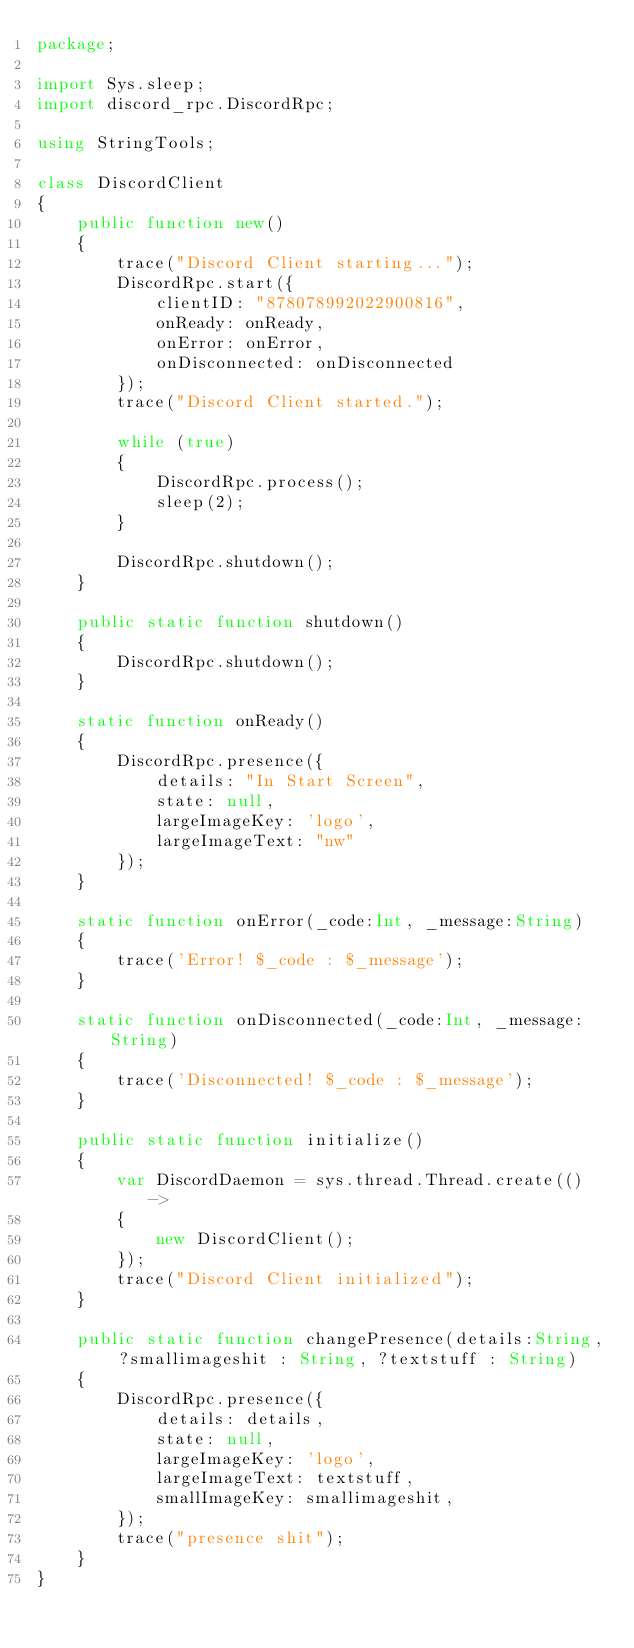<code> <loc_0><loc_0><loc_500><loc_500><_Haxe_>package;

import Sys.sleep;
import discord_rpc.DiscordRpc;

using StringTools;

class DiscordClient
{
	public function new()
	{
		trace("Discord Client starting...");
		DiscordRpc.start({
			clientID: "878078992022900816",
			onReady: onReady,
			onError: onError,
			onDisconnected: onDisconnected
		});
		trace("Discord Client started.");

		while (true)
		{
			DiscordRpc.process();
			sleep(2);
		}

		DiscordRpc.shutdown();
	}

	public static function shutdown()
	{
		DiscordRpc.shutdown();
	}

	static function onReady()
	{
		DiscordRpc.presence({
			details: "In Start Screen",
			state: null,
			largeImageKey: 'logo',
			largeImageText: "nw"
		});
	}

	static function onError(_code:Int, _message:String)
	{
		trace('Error! $_code : $_message');
	}

	static function onDisconnected(_code:Int, _message:String)
	{
		trace('Disconnected! $_code : $_message');
	}

	public static function initialize()
	{
		var DiscordDaemon = sys.thread.Thread.create(() ->
		{
			new DiscordClient();
		});
		trace("Discord Client initialized");
	}

	public static function changePresence(details:String, ?smallimageshit : String, ?textstuff : String)
	{
		DiscordRpc.presence({
			details: details,
			state: null,
			largeImageKey: 'logo',
			largeImageText: textstuff,
			smallImageKey: smallimageshit,
		});
		trace("presence shit");
	}
}</code> 